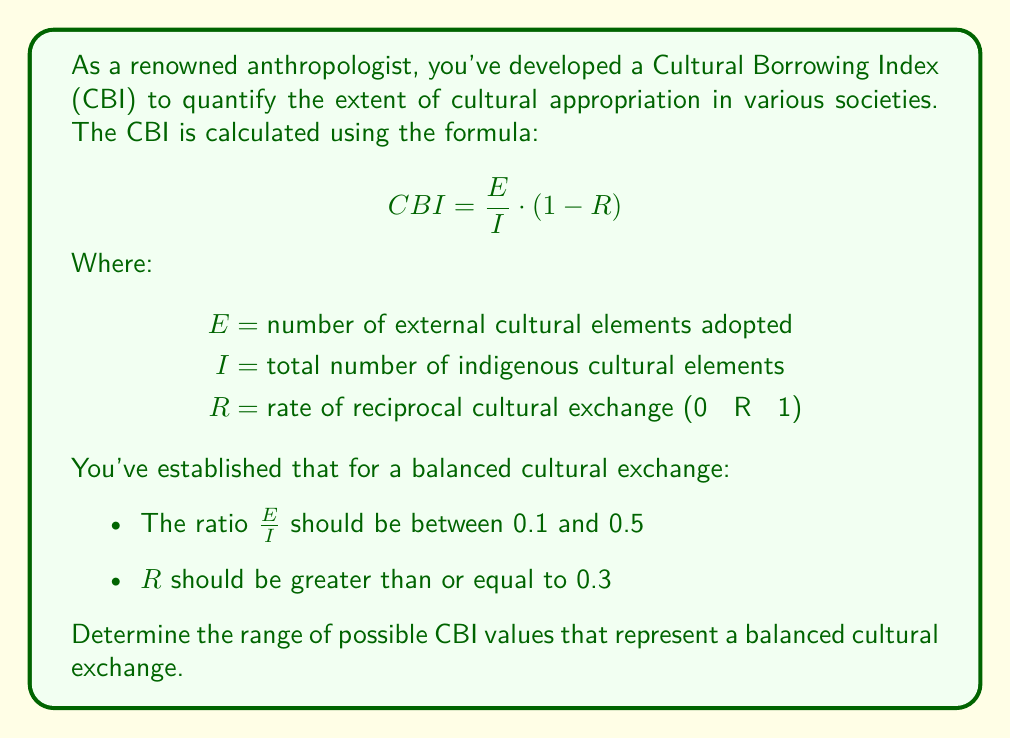Could you help me with this problem? To solve this problem, we need to consider the constraints given and apply them to the CBI formula:

1. First, let's consider the constraints:
   $0.1 \leq \frac{E}{I} \leq 0.5$
   $0.3 \leq R \leq 1$

2. We need to find the minimum and maximum possible CBI values within these constraints.

3. For the minimum CBI:
   - Use the minimum value of $\frac{E}{I}$ (0.1)
   - Use the maximum value of $R$ (1)
   
   $CBI_{min} = 0.1 \cdot (1 - 1) = 0$

4. For the maximum CBI:
   - Use the maximum value of $\frac{E}{I}$ (0.5)
   - Use the minimum value of $R$ (0.3)
   
   $CBI_{max} = 0.5 \cdot (1 - 0.3) = 0.5 \cdot 0.7 = 0.35$

5. Therefore, the range of CBI values for a balanced cultural exchange is:

   $0 \leq CBI \leq 0.35$
Answer: The range of possible CBI values representing a balanced cultural exchange is $[0, 0.35]$. 